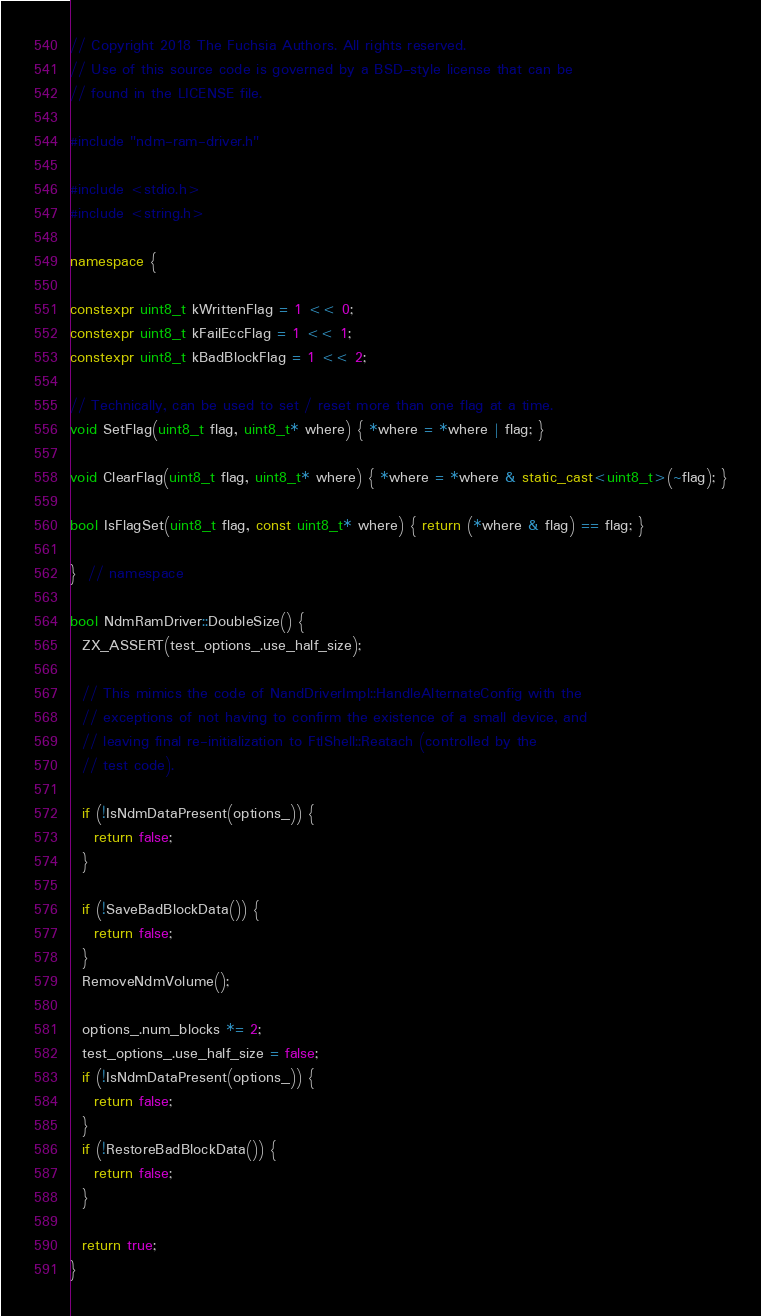Convert code to text. <code><loc_0><loc_0><loc_500><loc_500><_C++_>// Copyright 2018 The Fuchsia Authors. All rights reserved.
// Use of this source code is governed by a BSD-style license that can be
// found in the LICENSE file.

#include "ndm-ram-driver.h"

#include <stdio.h>
#include <string.h>

namespace {

constexpr uint8_t kWrittenFlag = 1 << 0;
constexpr uint8_t kFailEccFlag = 1 << 1;
constexpr uint8_t kBadBlockFlag = 1 << 2;

// Technically, can be used to set / reset more than one flag at a time.
void SetFlag(uint8_t flag, uint8_t* where) { *where = *where | flag; }

void ClearFlag(uint8_t flag, uint8_t* where) { *where = *where & static_cast<uint8_t>(~flag); }

bool IsFlagSet(uint8_t flag, const uint8_t* where) { return (*where & flag) == flag; }

}  // namespace

bool NdmRamDriver::DoubleSize() {
  ZX_ASSERT(test_options_.use_half_size);

  // This mimics the code of NandDriverImpl::HandleAlternateConfig with the
  // exceptions of not having to confirm the existence of a small device, and
  // leaving final re-initialization to FtlShell::Reatach (controlled by the
  // test code).

  if (!IsNdmDataPresent(options_)) {
    return false;
  }

  if (!SaveBadBlockData()) {
    return false;
  }
  RemoveNdmVolume();

  options_.num_blocks *= 2;
  test_options_.use_half_size = false;
  if (!IsNdmDataPresent(options_)) {
    return false;
  }
  if (!RestoreBadBlockData()) {
    return false;
  }

  return true;
}
</code> 